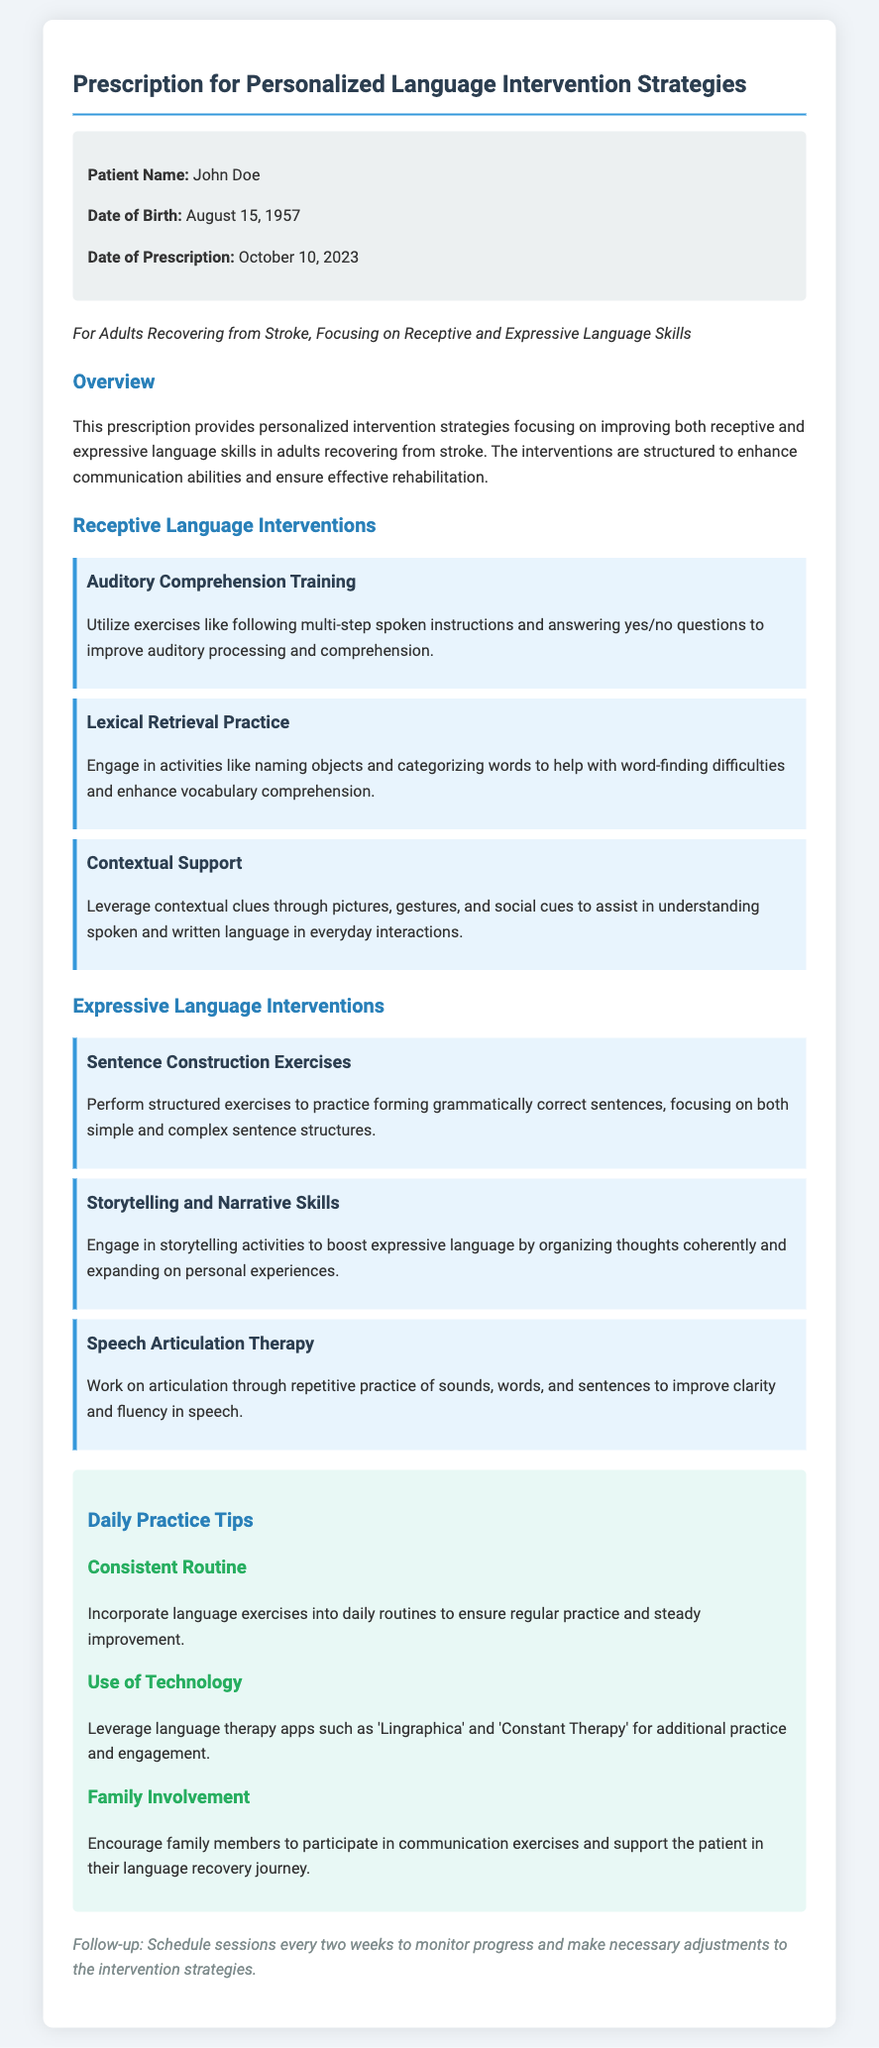What is the patient's name? The patient's name is provided in the patient details section of the document.
Answer: John Doe What is the date of birth of the patient? The date of birth can be found in the patient details section of the document.
Answer: August 15, 1957 When was the prescription written? The date of prescription is mentioned towards the beginning of the document.
Answer: October 10, 2023 What is the focus of the interventions? The focus of the interventions is stated in the subtitle of the document.
Answer: Receptive and Expressive Language Skills What type of training is included in Receptive Language Interventions? The specific type of training is listed in the Receptive Language Interventions section of the document.
Answer: Auditory Comprehension Training Which app is suggested for additional practice? The document mentions technology to leverage for language practice.
Answer: Lingraphica How often should follow-up sessions be scheduled? The follow-up frequency is indicated towards the end of the prescription document.
Answer: Every two weeks What is the first tip provided in Daily Practice Tips? The document lists daily practice tips that provide guidance for consistent improvement.
Answer: Consistent Routine How many expressive language interventions are mentioned? The document outlines the total number of interventions provided in the Expressive Language Interventions section.
Answer: Three 